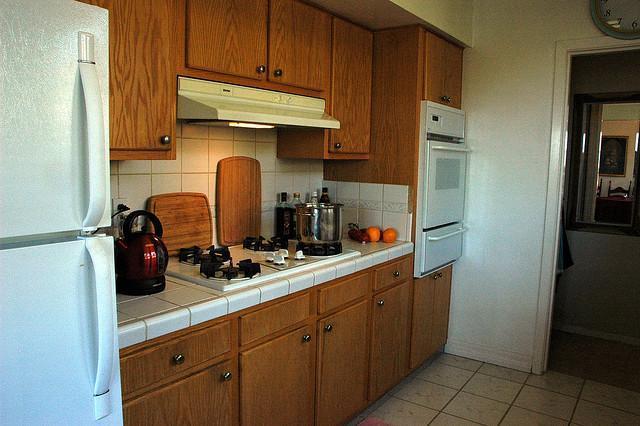How many doors are on the train car?
Give a very brief answer. 0. 